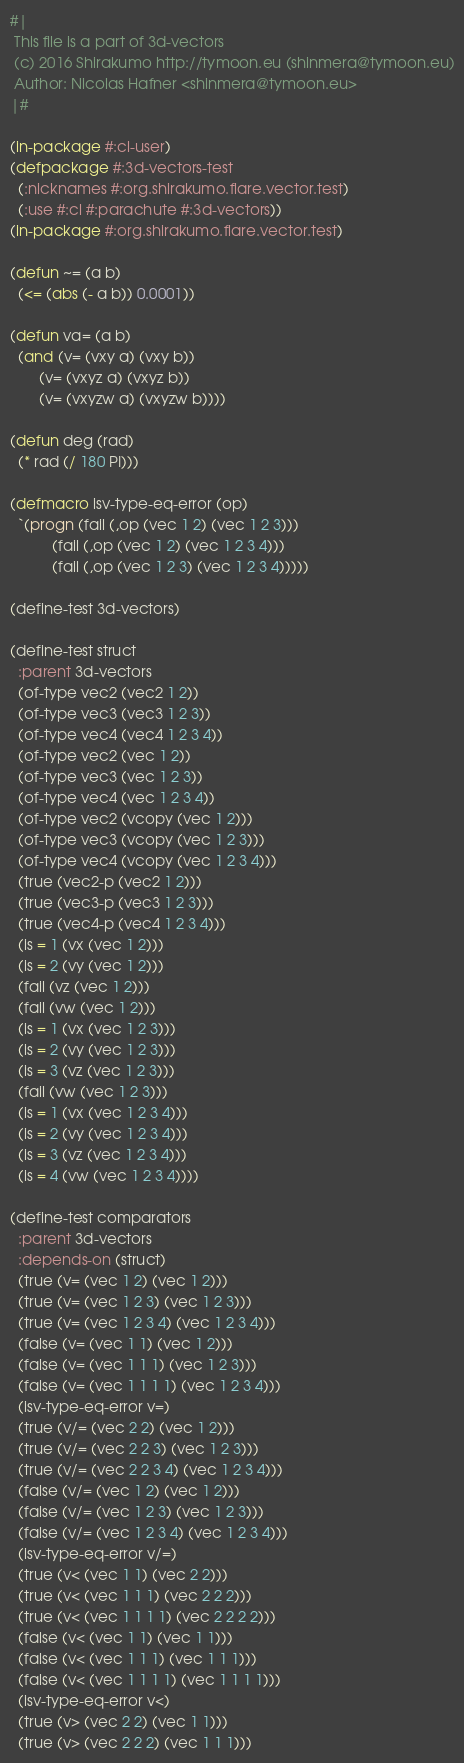Convert code to text. <code><loc_0><loc_0><loc_500><loc_500><_Lisp_>#|
 This file is a part of 3d-vectors
 (c) 2016 Shirakumo http://tymoon.eu (shinmera@tymoon.eu)
 Author: Nicolas Hafner <shinmera@tymoon.eu>
|#

(in-package #:cl-user)
(defpackage #:3d-vectors-test
  (:nicknames #:org.shirakumo.flare.vector.test)
  (:use #:cl #:parachute #:3d-vectors))
(in-package #:org.shirakumo.flare.vector.test)

(defun ~= (a b)
  (<= (abs (- a b)) 0.0001))

(defun va= (a b)
  (and (v= (vxy a) (vxy b))
       (v= (vxyz a) (vxyz b))
       (v= (vxyzw a) (vxyzw b))))

(defun deg (rad)
  (* rad (/ 180 PI)))

(defmacro isv-type-eq-error (op)
  `(progn (fail (,op (vec 1 2) (vec 1 2 3)))
          (fail (,op (vec 1 2) (vec 1 2 3 4)))
          (fail (,op (vec 1 2 3) (vec 1 2 3 4))))) 

(define-test 3d-vectors)

(define-test struct
  :parent 3d-vectors
  (of-type vec2 (vec2 1 2))
  (of-type vec3 (vec3 1 2 3))
  (of-type vec4 (vec4 1 2 3 4))
  (of-type vec2 (vec 1 2))
  (of-type vec3 (vec 1 2 3))
  (of-type vec4 (vec 1 2 3 4))
  (of-type vec2 (vcopy (vec 1 2)))
  (of-type vec3 (vcopy (vec 1 2 3)))
  (of-type vec4 (vcopy (vec 1 2 3 4)))
  (true (vec2-p (vec2 1 2)))
  (true (vec3-p (vec3 1 2 3)))
  (true (vec4-p (vec4 1 2 3 4)))
  (is = 1 (vx (vec 1 2)))
  (is = 2 (vy (vec 1 2)))
  (fail (vz (vec 1 2)))
  (fail (vw (vec 1 2)))
  (is = 1 (vx (vec 1 2 3)))
  (is = 2 (vy (vec 1 2 3)))
  (is = 3 (vz (vec 1 2 3)))
  (fail (vw (vec 1 2 3)))
  (is = 1 (vx (vec 1 2 3 4)))
  (is = 2 (vy (vec 1 2 3 4)))
  (is = 3 (vz (vec 1 2 3 4)))
  (is = 4 (vw (vec 1 2 3 4))))

(define-test comparators
  :parent 3d-vectors
  :depends-on (struct)
  (true (v= (vec 1 2) (vec 1 2)))
  (true (v= (vec 1 2 3) (vec 1 2 3)))
  (true (v= (vec 1 2 3 4) (vec 1 2 3 4)))
  (false (v= (vec 1 1) (vec 1 2)))
  (false (v= (vec 1 1 1) (vec 1 2 3)))
  (false (v= (vec 1 1 1 1) (vec 1 2 3 4)))
  (isv-type-eq-error v=)
  (true (v/= (vec 2 2) (vec 1 2)))
  (true (v/= (vec 2 2 3) (vec 1 2 3)))
  (true (v/= (vec 2 2 3 4) (vec 1 2 3 4)))
  (false (v/= (vec 1 2) (vec 1 2)))
  (false (v/= (vec 1 2 3) (vec 1 2 3)))
  (false (v/= (vec 1 2 3 4) (vec 1 2 3 4)))
  (isv-type-eq-error v/=)
  (true (v< (vec 1 1) (vec 2 2)))
  (true (v< (vec 1 1 1) (vec 2 2 2)))
  (true (v< (vec 1 1 1 1) (vec 2 2 2 2)))
  (false (v< (vec 1 1) (vec 1 1)))
  (false (v< (vec 1 1 1) (vec 1 1 1)))
  (false (v< (vec 1 1 1 1) (vec 1 1 1 1)))
  (isv-type-eq-error v<)
  (true (v> (vec 2 2) (vec 1 1)))
  (true (v> (vec 2 2 2) (vec 1 1 1)))</code> 